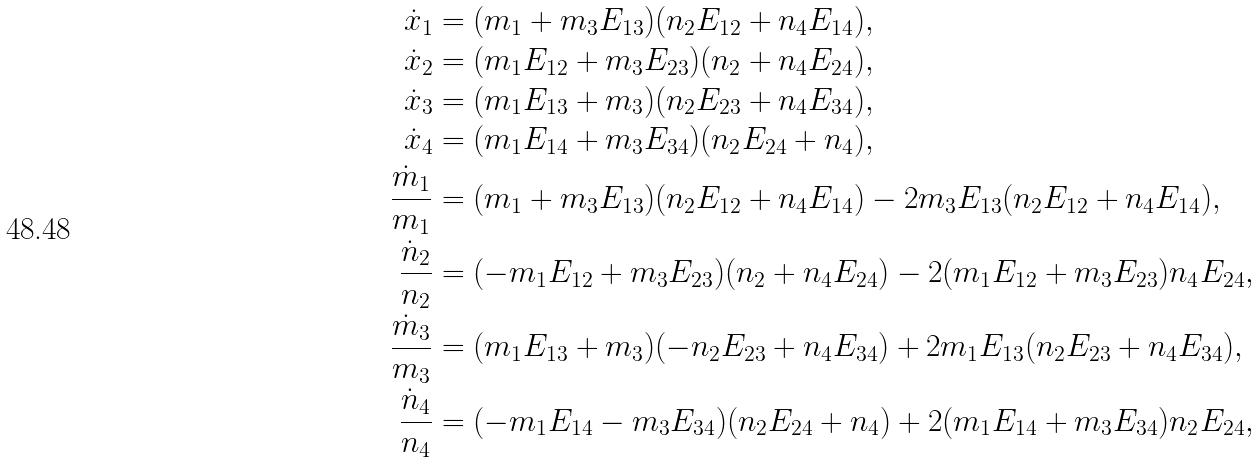Convert formula to latex. <formula><loc_0><loc_0><loc_500><loc_500>\dot { x } _ { 1 } & = ( m _ { 1 } + m _ { 3 } E _ { 1 3 } ) ( n _ { 2 } E _ { 1 2 } + n _ { 4 } E _ { 1 4 } ) , \\ \dot { x } _ { 2 } & = ( m _ { 1 } E _ { 1 2 } + m _ { 3 } E _ { 2 3 } ) ( n _ { 2 } + n _ { 4 } E _ { 2 4 } ) , \\ \dot { x } _ { 3 } & = ( m _ { 1 } E _ { 1 3 } + m _ { 3 } ) ( n _ { 2 } E _ { 2 3 } + n _ { 4 } E _ { 3 4 } ) , \\ \dot { x } _ { 4 } & = ( m _ { 1 } E _ { 1 4 } + m _ { 3 } E _ { 3 4 } ) ( n _ { 2 } E _ { 2 4 } + n _ { 4 } ) , \\ \frac { \dot { m } _ { 1 } } { m _ { 1 } } & = ( m _ { 1 } + m _ { 3 } E _ { 1 3 } ) ( n _ { 2 } E _ { 1 2 } + n _ { 4 } E _ { 1 4 } ) - 2 m _ { 3 } E _ { 1 3 } ( n _ { 2 } E _ { 1 2 } + n _ { 4 } E _ { 1 4 } ) , \\ \frac { \dot { n } _ { 2 } } { n _ { 2 } } & = ( - m _ { 1 } E _ { 1 2 } + m _ { 3 } E _ { 2 3 } ) ( n _ { 2 } + n _ { 4 } E _ { 2 4 } ) - 2 ( m _ { 1 } E _ { 1 2 } + m _ { 3 } E _ { 2 3 } ) n _ { 4 } E _ { 2 4 } , \\ \frac { \dot { m } _ { 3 } } { m _ { 3 } } & = ( m _ { 1 } E _ { 1 3 } + m _ { 3 } ) ( - n _ { 2 } E _ { 2 3 } + n _ { 4 } E _ { 3 4 } ) + 2 m _ { 1 } E _ { 1 3 } ( n _ { 2 } E _ { 2 3 } + n _ { 4 } E _ { 3 4 } ) , \\ \frac { \dot { n } _ { 4 } } { n _ { 4 } } & = ( - m _ { 1 } E _ { 1 4 } - m _ { 3 } E _ { 3 4 } ) ( n _ { 2 } E _ { 2 4 } + n _ { 4 } ) + 2 ( m _ { 1 } E _ { 1 4 } + m _ { 3 } E _ { 3 4 } ) n _ { 2 } E _ { 2 4 } ,</formula> 